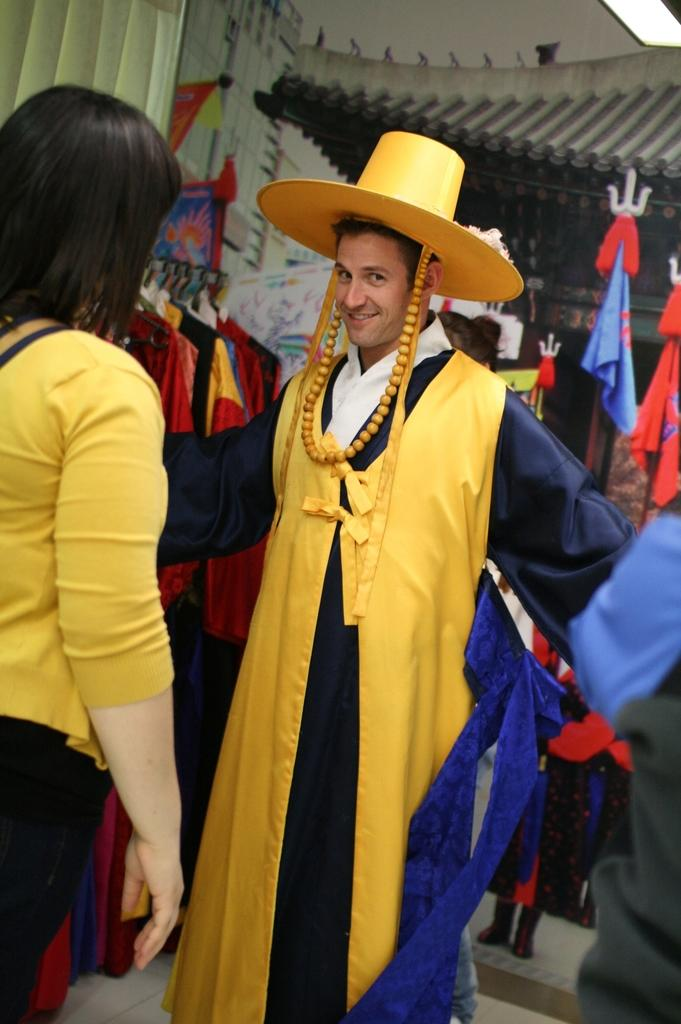What is the appearance of the person in the image? There is a man in the image, and he is wearing a costume and a hat. What is the man doing in the image? The man is looking at someone. Who else is present in the image? There is a woman in the image. How is the woman positioned in relation to the man? The woman is standing in front of the man. What type of iron is the man using to press his costume in the image? There is no iron present in the image, and the man is not pressing his costume. 